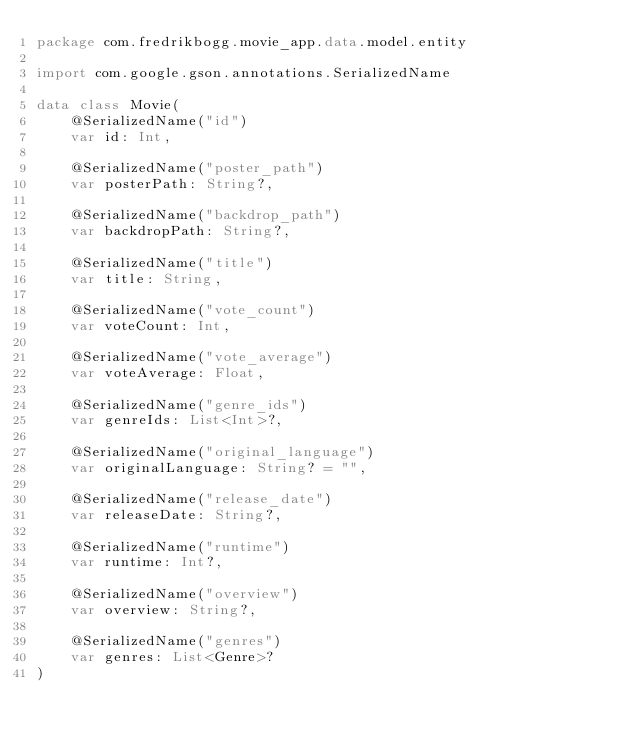Convert code to text. <code><loc_0><loc_0><loc_500><loc_500><_Kotlin_>package com.fredrikbogg.movie_app.data.model.entity

import com.google.gson.annotations.SerializedName

data class Movie(
    @SerializedName("id")
    var id: Int,

    @SerializedName("poster_path")
    var posterPath: String?,

    @SerializedName("backdrop_path")
    var backdropPath: String?,

    @SerializedName("title")
    var title: String,

    @SerializedName("vote_count")
    var voteCount: Int,

    @SerializedName("vote_average")
    var voteAverage: Float,

    @SerializedName("genre_ids")
    var genreIds: List<Int>?,

    @SerializedName("original_language")
    var originalLanguage: String? = "",

    @SerializedName("release_date")
    var releaseDate: String?,

    @SerializedName("runtime")
    var runtime: Int?,

    @SerializedName("overview")
    var overview: String?,

    @SerializedName("genres")
    var genres: List<Genre>?
)

</code> 